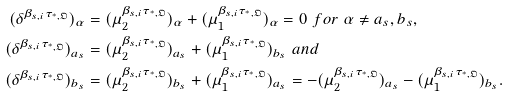Convert formula to latex. <formula><loc_0><loc_0><loc_500><loc_500>( \delta ^ { \beta _ { s , i } \tau _ { ^ { * } , \mathfrak { O } } } ) _ { \alpha } & = ( \mu _ { 2 } ^ { \beta _ { s , i } \tau _ { ^ { * } , \mathfrak { O } } } ) _ { \alpha } + ( \mu _ { 1 } ^ { \beta _ { s , i } \tau _ { ^ { * } , \mathfrak { O } } } ) _ { \alpha } = 0 \ f o r \ \alpha \neq a _ { s } , b _ { s } , \\ ( \delta ^ { \beta _ { s , i } \tau _ { ^ { * } , \mathfrak { O } } } ) _ { a _ { s } } & = ( \mu _ { 2 } ^ { \beta _ { s , i } \tau _ { ^ { * } , \mathfrak { O } } } ) _ { a _ { s } } + ( \mu _ { 1 } ^ { \beta _ { s , i } \tau _ { ^ { * } , \mathfrak { O } } } ) _ { b _ { s } } \ a n d \\ ( \delta ^ { \beta _ { s , i } \tau _ { ^ { * } , \mathfrak { O } } } ) _ { b _ { s } } & = ( \mu _ { 2 } ^ { \beta _ { s , i } \tau _ { ^ { * } , \mathfrak { O } } } ) _ { b _ { s } } + ( \mu _ { 1 } ^ { \beta _ { s , i } \tau _ { ^ { * } , \mathfrak { O } } } ) _ { a _ { s } } = - ( \mu _ { 2 } ^ { \beta _ { s , i } \tau _ { ^ { * } , \mathfrak { O } } } ) _ { a _ { s } } - ( \mu _ { 1 } ^ { \beta _ { s , i } \tau _ { ^ { * } , \mathfrak { O } } } ) _ { b _ { s } } .</formula> 